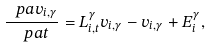<formula> <loc_0><loc_0><loc_500><loc_500>\frac { \ p a v _ { i , \gamma } } { \ p a t } = L ^ { \gamma } _ { i , t } v _ { i , \gamma } - v _ { i , \gamma } + E _ { i } ^ { \gamma } ,</formula> 